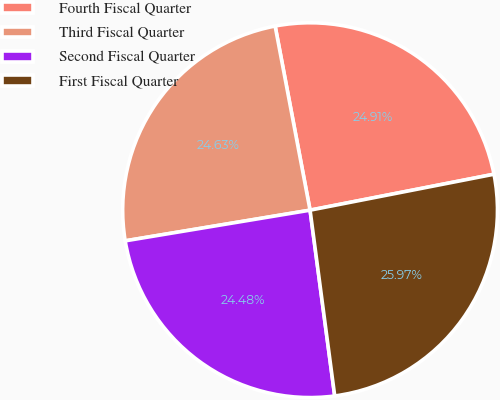Convert chart. <chart><loc_0><loc_0><loc_500><loc_500><pie_chart><fcel>Fourth Fiscal Quarter<fcel>Third Fiscal Quarter<fcel>Second Fiscal Quarter<fcel>First Fiscal Quarter<nl><fcel>24.91%<fcel>24.63%<fcel>24.48%<fcel>25.97%<nl></chart> 